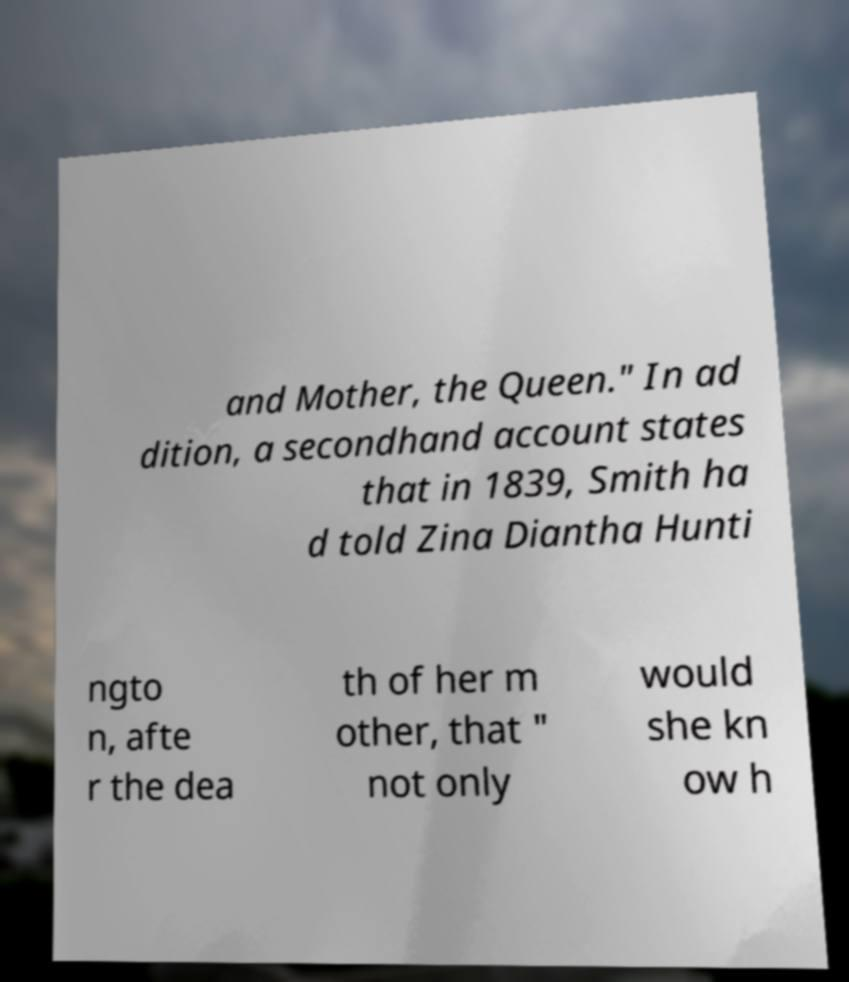Please identify and transcribe the text found in this image. and Mother, the Queen." In ad dition, a secondhand account states that in 1839, Smith ha d told Zina Diantha Hunti ngto n, afte r the dea th of her m other, that " not only would she kn ow h 